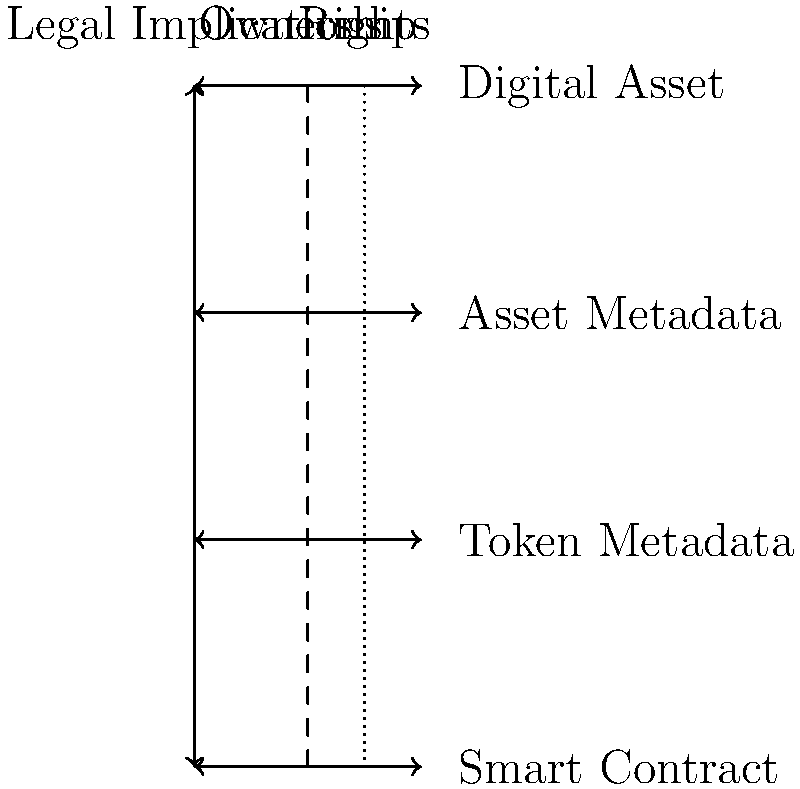In the context of NFT tokenization, which layer of metadata is most critical for determining the scope of intellectual property rights, and why does this have significant legal implications? To answer this question, we need to consider the layers of NFT metadata and their legal implications:

1. Smart Contract: This is the foundational layer that defines the basic rules of the NFT, such as ownership transfer and royalties. While important, it doesn't typically contain detailed IP rights information.

2. Token Metadata: This layer contains information specific to the NFT, such as its unique identifier and basic descriptive data. It's important for identification but doesn't usually define IP rights in detail.

3. Asset Metadata: This is the critical layer for IP rights. It typically includes:
   a) Detailed description of the digital asset
   b) Creator information
   c) Licensing terms
   d) Usage rights
   e) Restrictions on reproduction or modification

4. Digital Asset: This is the actual content (e.g., image, video, audio) but doesn't inherently contain rights information.

The Asset Metadata layer is most critical for determining IP rights because:

1. It provides the most comprehensive information about the rights associated with the NFT.
2. It can include specific licensing terms that define how the asset can be used.
3. It bridges the gap between the blockchain-based token and the legal realm of intellectual property.

Legal implications:
1. Clarity of Rights: Precise metadata helps prevent disputes over usage rights.
2. Enforceability: Well-defined terms in the metadata can be more easily enforced in legal proceedings.
3. Compliance: Clear metadata helps ensure compliance with copyright laws and licensing agreements.
4. Transferability: It defines what rights are transferred with the NFT ownership.
5. Valuation: The scope of rights significantly impacts the NFT's value.

Therefore, the Asset Metadata layer is most critical for determining IP rights in NFT tokenization, with significant legal implications for ownership, usage, and value.
Answer: Asset Metadata layer 